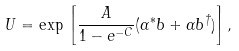<formula> <loc_0><loc_0><loc_500><loc_500>U = \exp \, \left [ \frac { A } { 1 - e ^ { - C } } ( \alpha ^ { * } b + \alpha b ^ { \dag } ) \right ] ,</formula> 